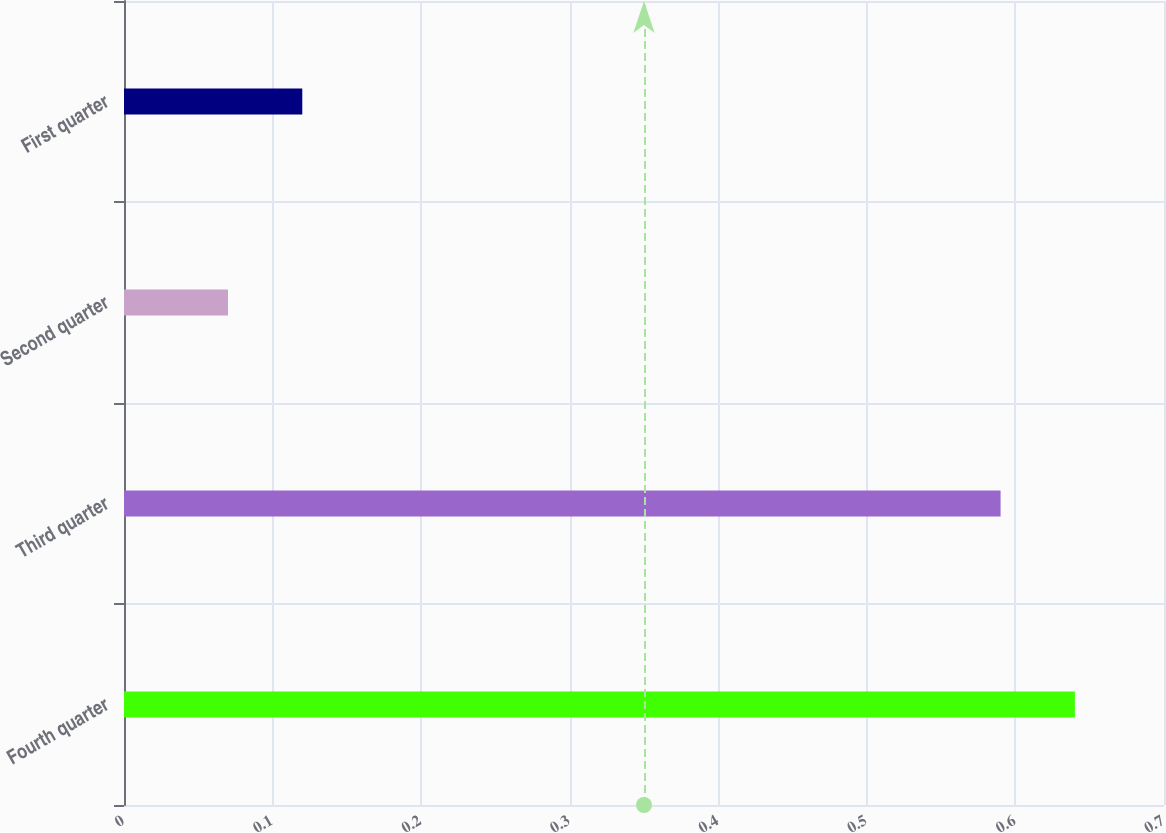Convert chart. <chart><loc_0><loc_0><loc_500><loc_500><bar_chart><fcel>Fourth quarter<fcel>Third quarter<fcel>Second quarter<fcel>First quarter<nl><fcel>0.64<fcel>0.59<fcel>0.07<fcel>0.12<nl></chart> 